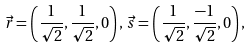<formula> <loc_0><loc_0><loc_500><loc_500>\vec { r } = \left ( \frac { 1 } { \sqrt { 2 } } , \frac { 1 } { \sqrt { 2 } } , 0 \right ) , \, \vec { s } = \left ( \frac { 1 } { \sqrt { 2 } } , \frac { - 1 } { \sqrt { 2 } } , 0 \right ) ,</formula> 